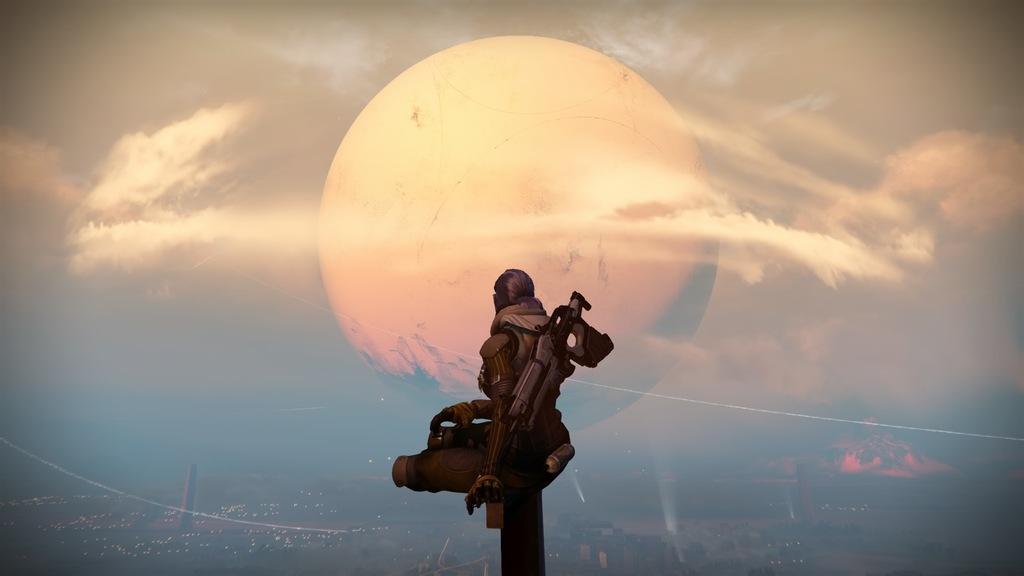Can you describe this image briefly? This is an animated image where we can see a person, the sky and the moon. At the bottom of the image, we can see the city. 